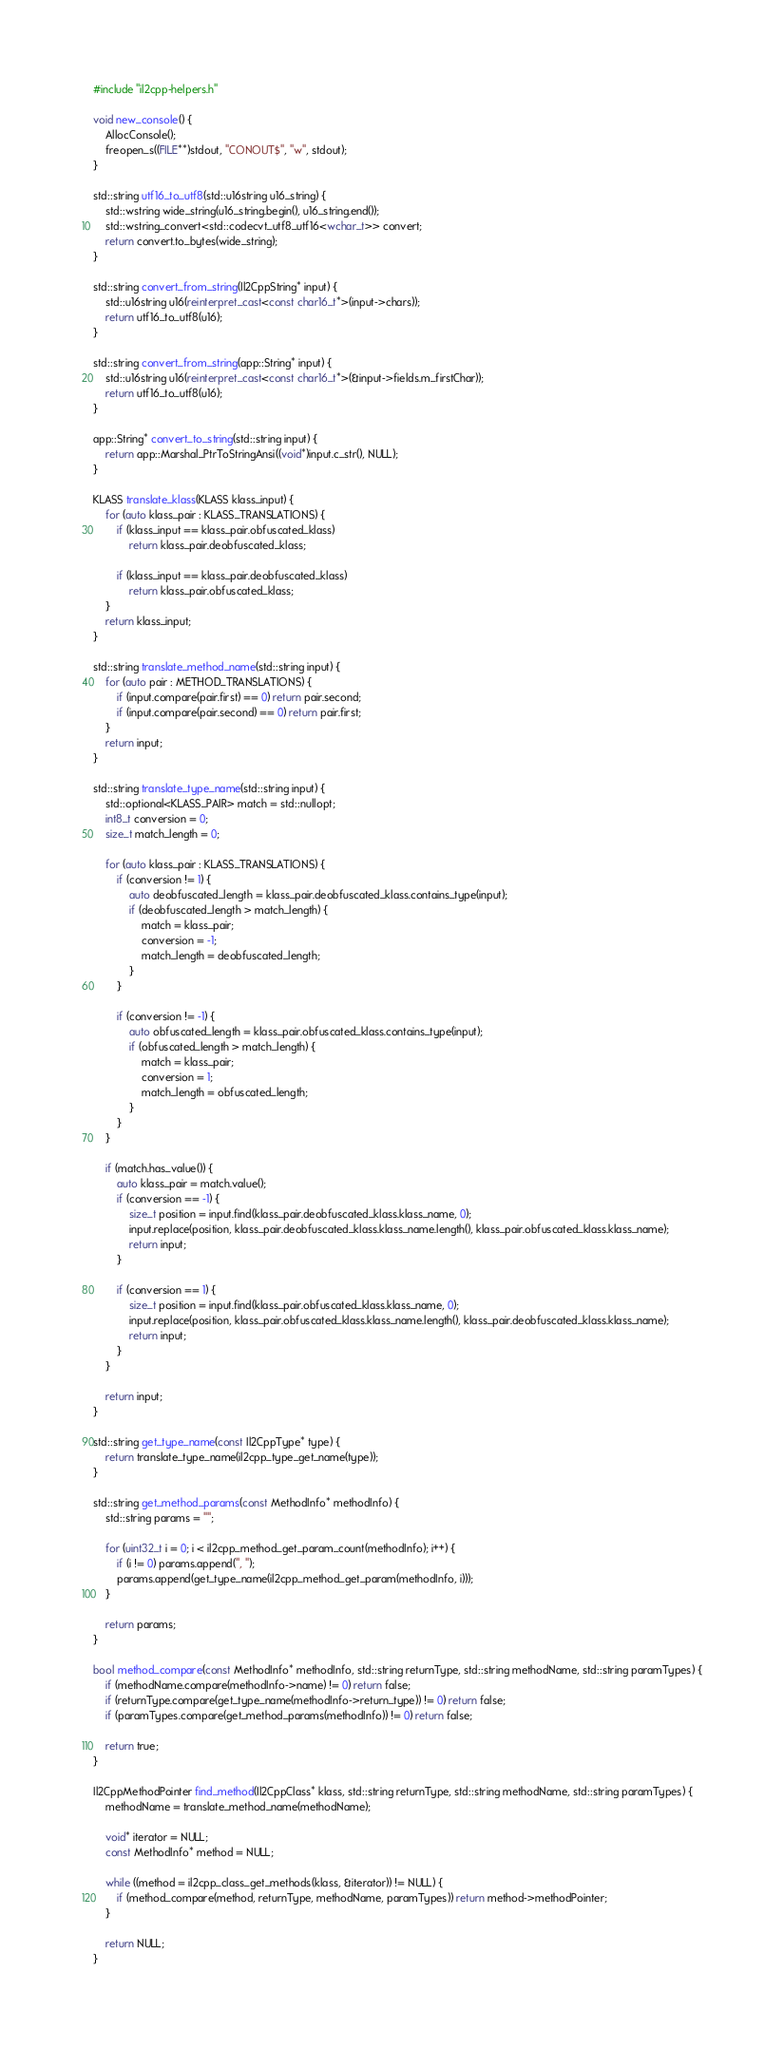Convert code to text. <code><loc_0><loc_0><loc_500><loc_500><_C++_>#include "il2cpp-helpers.h"

void new_console() {
	AllocConsole();
	freopen_s((FILE**)stdout, "CONOUT$", "w", stdout);
}

std::string utf16_to_utf8(std::u16string u16_string) {
	std::wstring wide_string(u16_string.begin(), u16_string.end());
	std::wstring_convert<std::codecvt_utf8_utf16<wchar_t>> convert;
	return convert.to_bytes(wide_string);
}

std::string convert_from_string(Il2CppString* input) {
	std::u16string u16(reinterpret_cast<const char16_t*>(input->chars));
	return utf16_to_utf8(u16);
}

std::string convert_from_string(app::String* input) {
	std::u16string u16(reinterpret_cast<const char16_t*>(&input->fields.m_firstChar));
	return utf16_to_utf8(u16);
}

app::String* convert_to_string(std::string input) {
	return app::Marshal_PtrToStringAnsi((void*)input.c_str(), NULL);
}

KLASS translate_klass(KLASS klass_input) {
	for (auto klass_pair : KLASS_TRANSLATIONS) {
		if (klass_input == klass_pair.obfuscated_klass)
			return klass_pair.deobfuscated_klass;

		if (klass_input == klass_pair.deobfuscated_klass)
			return klass_pair.obfuscated_klass;
	}
	return klass_input;
}

std::string translate_method_name(std::string input) {
	for (auto pair : METHOD_TRANSLATIONS) {
		if (input.compare(pair.first) == 0) return pair.second;
		if (input.compare(pair.second) == 0) return pair.first;
	}
	return input;
}

std::string translate_type_name(std::string input) {
	std::optional<KLASS_PAIR> match = std::nullopt;
	int8_t conversion = 0;
	size_t match_length = 0;

	for (auto klass_pair : KLASS_TRANSLATIONS) {
		if (conversion != 1) {
			auto deobfuscated_length = klass_pair.deobfuscated_klass.contains_type(input);
			if (deobfuscated_length > match_length) {
				match = klass_pair;
				conversion = -1;
				match_length = deobfuscated_length;
			}
		}

		if (conversion != -1) {
			auto obfuscated_length = klass_pair.obfuscated_klass.contains_type(input);
			if (obfuscated_length > match_length) {
				match = klass_pair;
				conversion = 1;
				match_length = obfuscated_length;
			}
		}
	}

	if (match.has_value()) {
		auto klass_pair = match.value();
		if (conversion == -1) {
			size_t position = input.find(klass_pair.deobfuscated_klass.klass_name, 0);
			input.replace(position, klass_pair.deobfuscated_klass.klass_name.length(), klass_pair.obfuscated_klass.klass_name);
			return input;
		}

		if (conversion == 1) {
			size_t position = input.find(klass_pair.obfuscated_klass.klass_name, 0);
			input.replace(position, klass_pair.obfuscated_klass.klass_name.length(), klass_pair.deobfuscated_klass.klass_name);
			return input;
		}
	}

	return input;
}

std::string get_type_name(const Il2CppType* type) {
	return translate_type_name(il2cpp_type_get_name(type));
}

std::string get_method_params(const MethodInfo* methodInfo) {
	std::string params = "";

	for (uint32_t i = 0; i < il2cpp_method_get_param_count(methodInfo); i++) {
		if (i != 0) params.append(", ");
		params.append(get_type_name(il2cpp_method_get_param(methodInfo, i)));
	}

	return params;
}

bool method_compare(const MethodInfo* methodInfo, std::string returnType, std::string methodName, std::string paramTypes) {
	if (methodName.compare(methodInfo->name) != 0) return false;
	if (returnType.compare(get_type_name(methodInfo->return_type)) != 0) return false;
	if (paramTypes.compare(get_method_params(methodInfo)) != 0) return false;

	return true;
}

Il2CppMethodPointer find_method(Il2CppClass* klass, std::string returnType, std::string methodName, std::string paramTypes) {
	methodName = translate_method_name(methodName);

	void* iterator = NULL;
	const MethodInfo* method = NULL;

	while ((method = il2cpp_class_get_methods(klass, &iterator)) != NULL) {
		if (method_compare(method, returnType, methodName, paramTypes)) return method->methodPointer;
	}

	return NULL;
}
</code> 